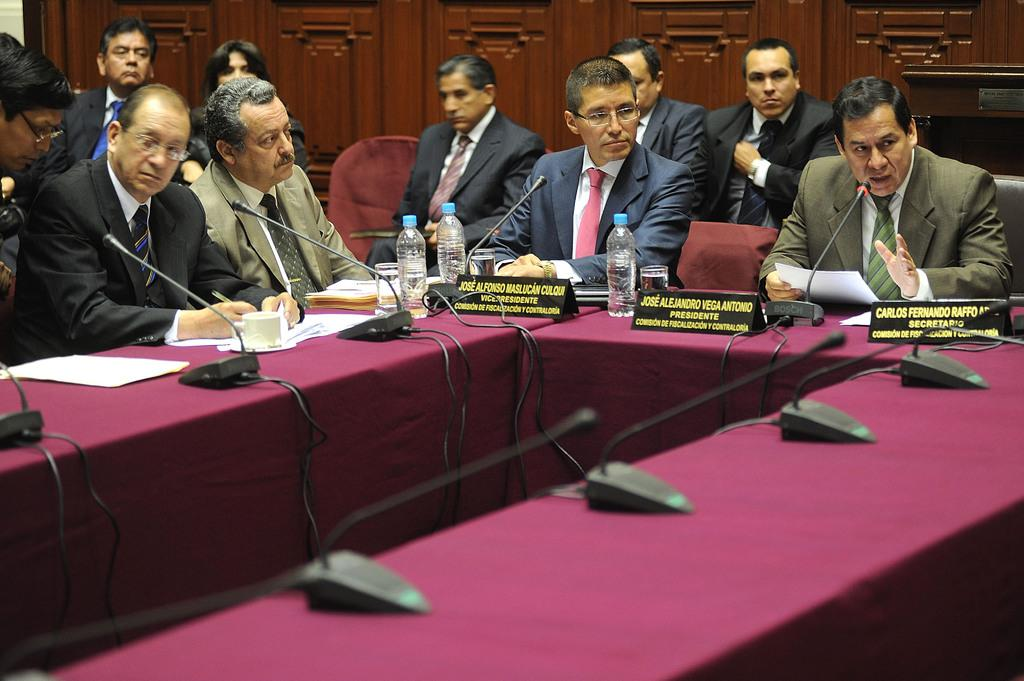How many people are in the image? There is a group of people in the image. What are the people doing in the image? The people are sitting on a chair, and one person is speaking on a microphone. Are there any other people in the image besides the one speaking? Yes, two people are observing the person who is speaking. What type of care is being provided in the bedroom in the image? There is no bedroom or care being provided in the image; it features a group of people with one person speaking on a microphone and two others observing. 